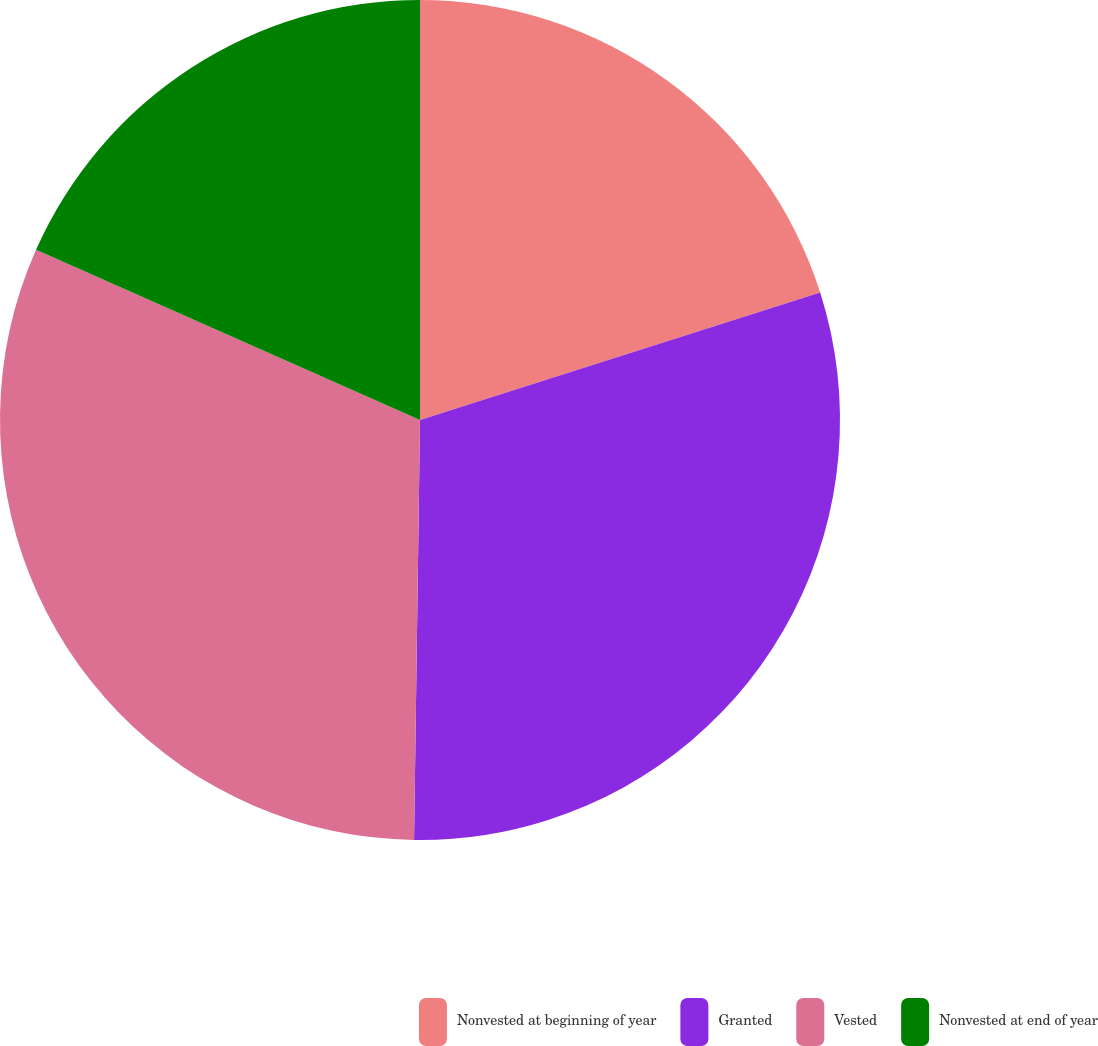Convert chart. <chart><loc_0><loc_0><loc_500><loc_500><pie_chart><fcel>Nonvested at beginning of year<fcel>Granted<fcel>Vested<fcel>Nonvested at end of year<nl><fcel>20.09%<fcel>30.13%<fcel>31.41%<fcel>18.36%<nl></chart> 